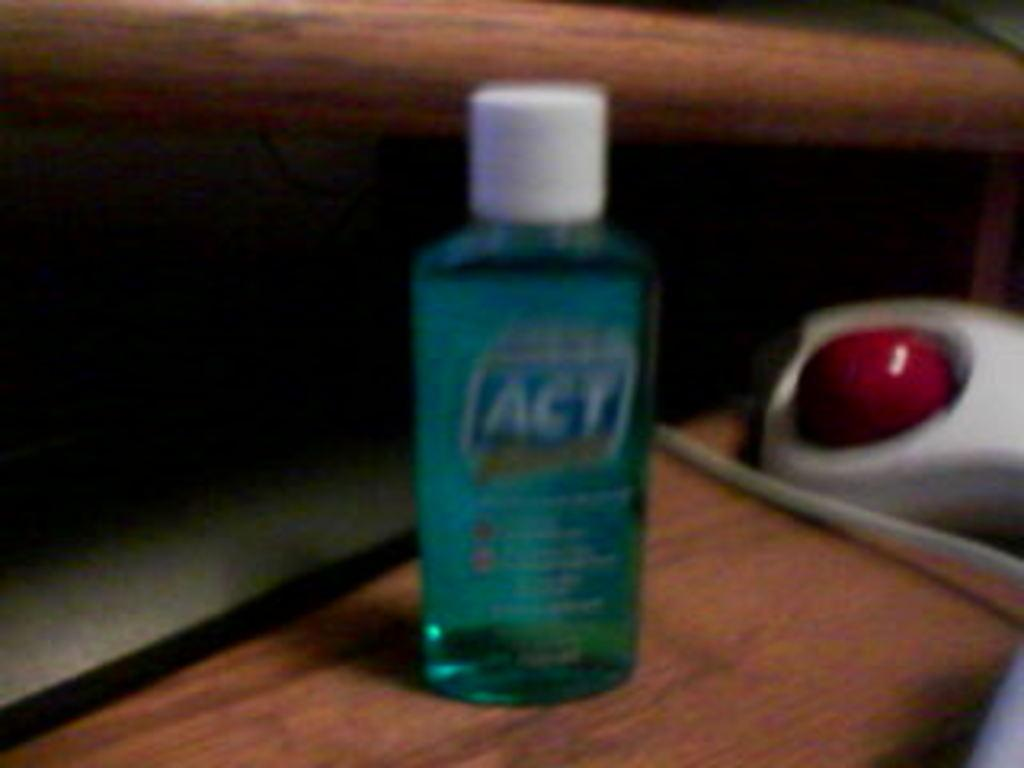Provide a one-sentence caption for the provided image. a blurry shot of ACT blue liquid on a wooden surface. 